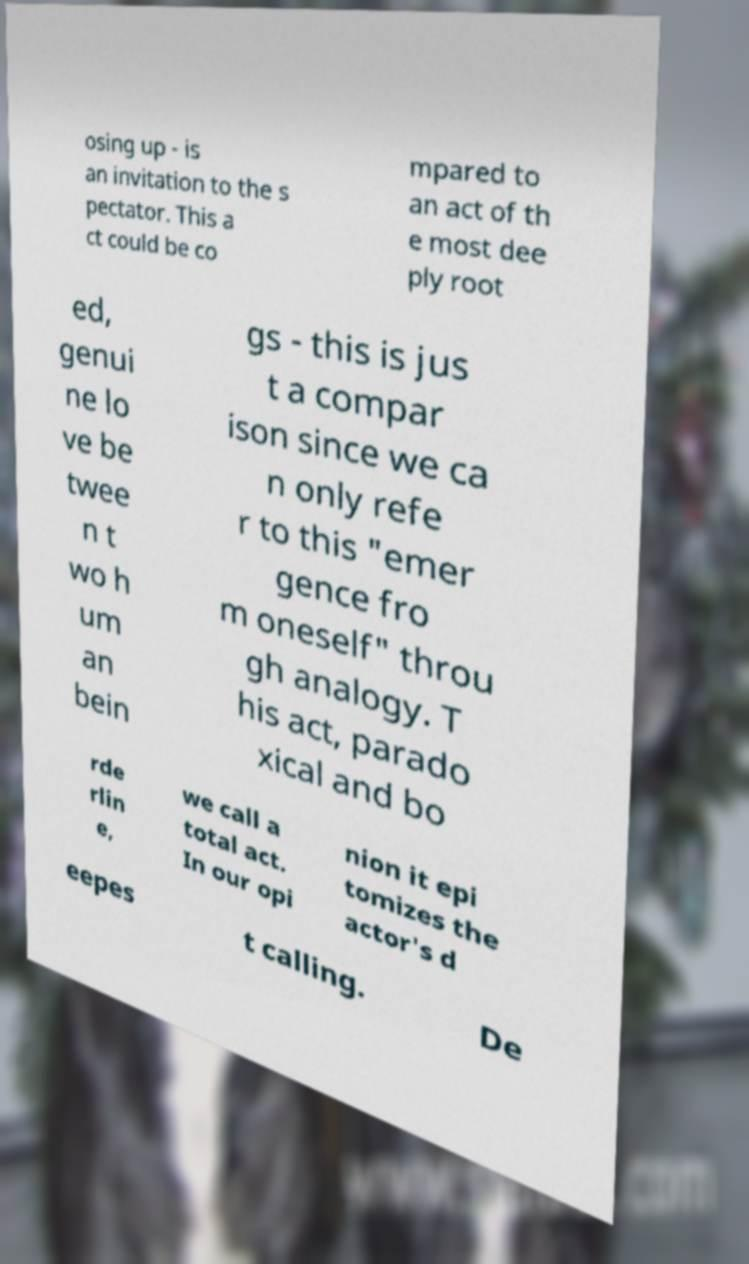Can you accurately transcribe the text from the provided image for me? osing up - is an invitation to the s pectator. This a ct could be co mpared to an act of th e most dee ply root ed, genui ne lo ve be twee n t wo h um an bein gs - this is jus t a compar ison since we ca n only refe r to this "emer gence fro m oneself" throu gh analogy. T his act, parado xical and bo rde rlin e, we call a total act. In our opi nion it epi tomizes the actor's d eepes t calling. De 